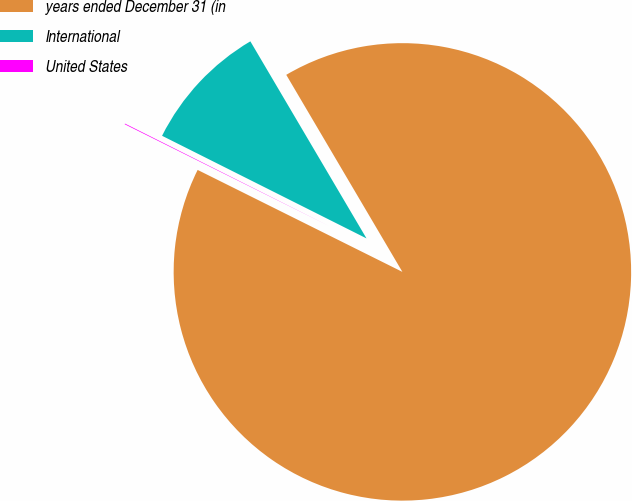<chart> <loc_0><loc_0><loc_500><loc_500><pie_chart><fcel>years ended December 31 (in<fcel>International<fcel>United States<nl><fcel>90.83%<fcel>9.12%<fcel>0.05%<nl></chart> 